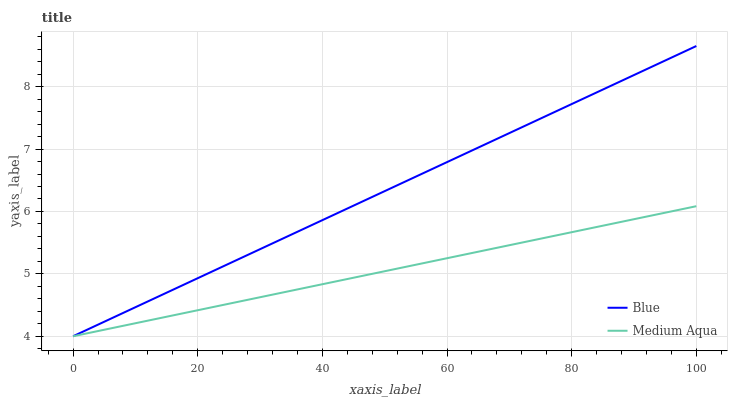Does Medium Aqua have the minimum area under the curve?
Answer yes or no. Yes. Does Blue have the maximum area under the curve?
Answer yes or no. Yes. Does Medium Aqua have the maximum area under the curve?
Answer yes or no. No. Is Medium Aqua the smoothest?
Answer yes or no. Yes. Is Blue the roughest?
Answer yes or no. Yes. Is Medium Aqua the roughest?
Answer yes or no. No. Does Blue have the lowest value?
Answer yes or no. Yes. Does Blue have the highest value?
Answer yes or no. Yes. Does Medium Aqua have the highest value?
Answer yes or no. No. Does Blue intersect Medium Aqua?
Answer yes or no. Yes. Is Blue less than Medium Aqua?
Answer yes or no. No. Is Blue greater than Medium Aqua?
Answer yes or no. No. 